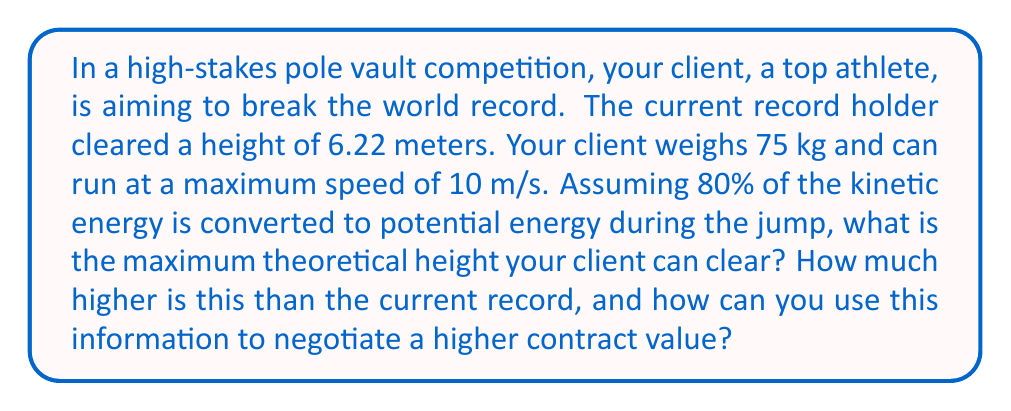What is the answer to this math problem? Let's approach this step-by-step:

1) First, we need to calculate the initial kinetic energy of the vaulter:
   
   $$E_k = \frac{1}{2}mv^2$$
   
   Where $m$ is the mass and $v$ is the velocity.
   
   $$E_k = \frac{1}{2} \cdot 75 \text{ kg} \cdot (10 \text{ m/s})^2 = 3750 \text{ J}$$

2) We're told that 80% of this energy is converted to potential energy:
   
   $$E_p = 0.8 \cdot 3750 \text{ J} = 3000 \text{ J}$$

3) The potential energy is given by:
   
   $$E_p = mgh$$
   
   Where $g$ is the acceleration due to gravity (9.8 m/s²) and $h$ is the height.

4) We can solve for $h$:
   
   $$h = \frac{E_p}{mg} = \frac{3000 \text{ J}}{75 \text{ kg} \cdot 9.8 \text{ m/s}^2} = 4.08 \text{ m}$$

5) The difference between this height and the current record is:
   
   $$4.08 \text{ m} - 6.22 \text{ m} = -2.14 \text{ m}$$

6) For negotiation purposes, you can argue that while the theoretical maximum is lower than the current record, it doesn't account for the athlete's technique, the energy stored in the pole, or other factors. You could claim that your client's superior technique could make up for this difference and potentially break the record, justifying a higher contract value.
Answer: 4.08 m; 2.14 m below record 